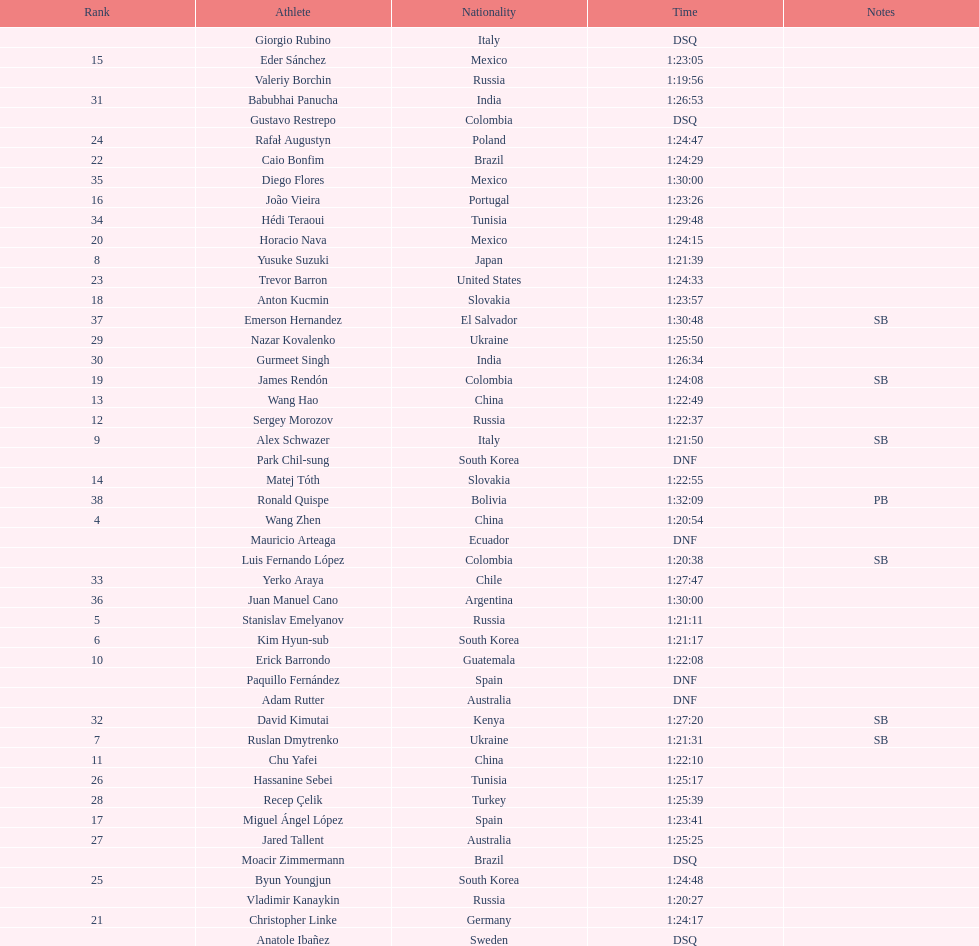What is the number of japanese in the top 10? 1. 